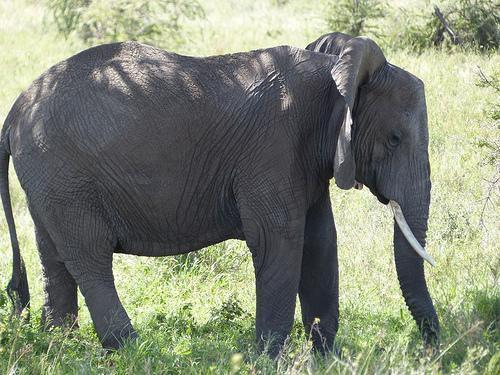How many elephants are there?
Give a very brief answer. 1. 